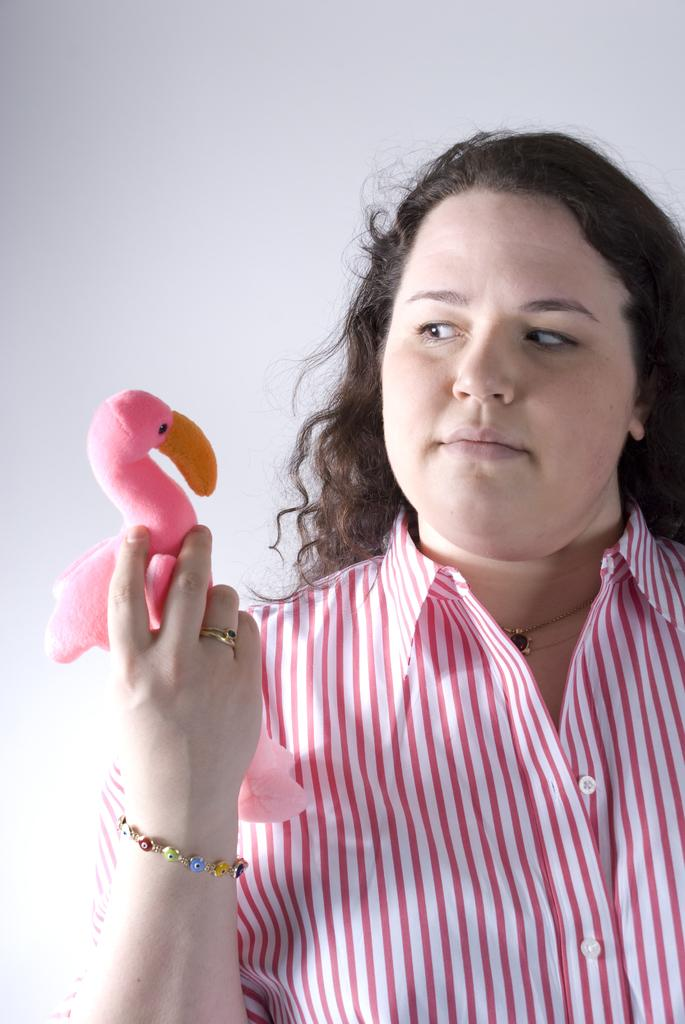Who is present in the image? There is a woman in the image. What is the woman wearing? The woman is wearing a shirt. What object is the woman holding? The woman is holding a pink doll. What color is the background of the image? The background of the image is white. Is the woman sleeping on a quilt in the image? There is no quilt or indication of the woman sleeping in the image. 